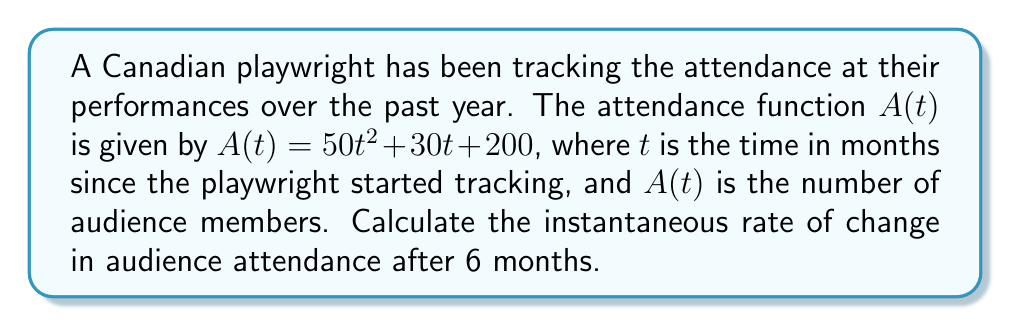Could you help me with this problem? To find the instantaneous rate of change in audience attendance after 6 months, we need to calculate the derivative of the attendance function $A(t)$ and evaluate it at $t = 6$.

1. The attendance function is given by:
   $A(t) = 50t^2 + 30t + 200$

2. To find the rate of change, we need to calculate the derivative $A'(t)$:
   $A'(t) = \frac{d}{dt}(50t^2 + 30t + 200)$
   $A'(t) = 100t + 30$

3. The instantaneous rate of change at $t = 6$ months is found by evaluating $A'(6)$:
   $A'(6) = 100(6) + 30$
   $A'(6) = 600 + 30$
   $A'(6) = 630$

Therefore, the instantaneous rate of change in audience attendance after 6 months is 630 people per month.
Answer: 630 people per month 